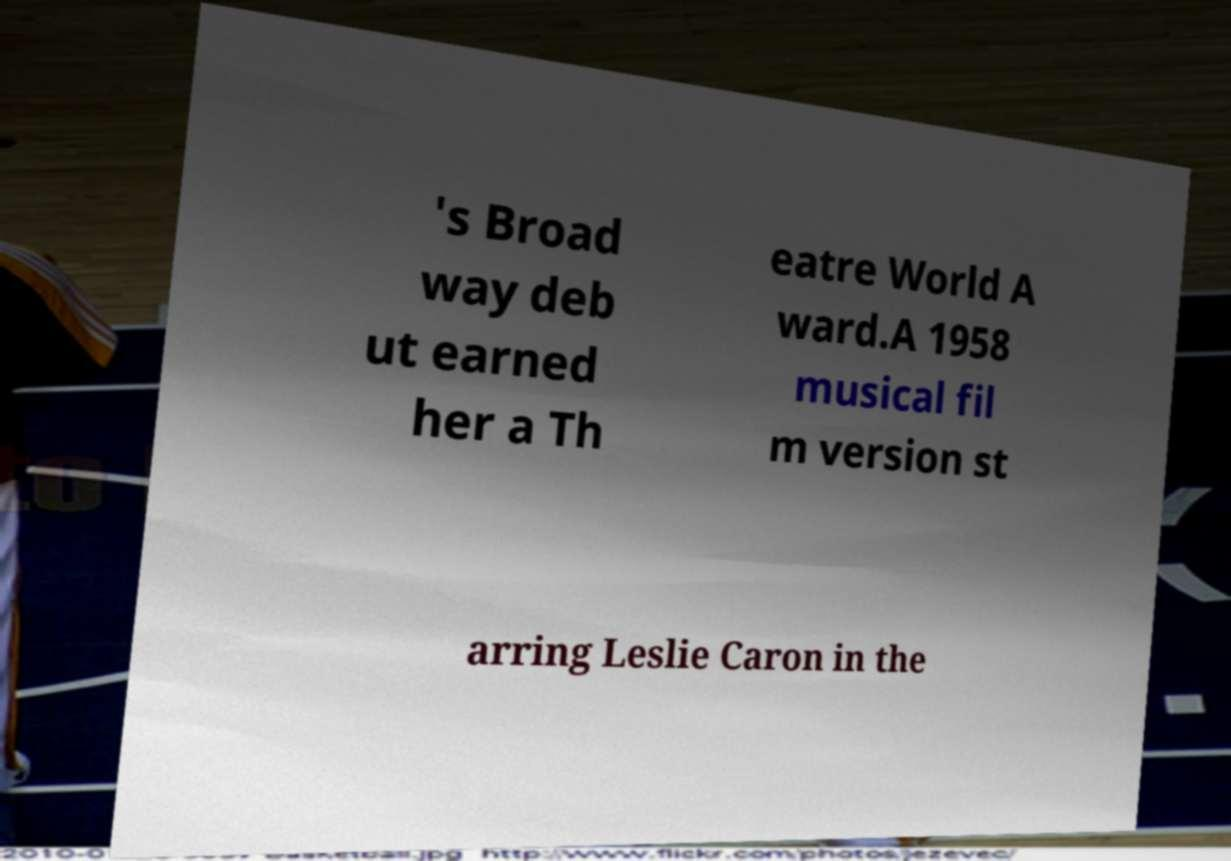For documentation purposes, I need the text within this image transcribed. Could you provide that? 's Broad way deb ut earned her a Th eatre World A ward.A 1958 musical fil m version st arring Leslie Caron in the 